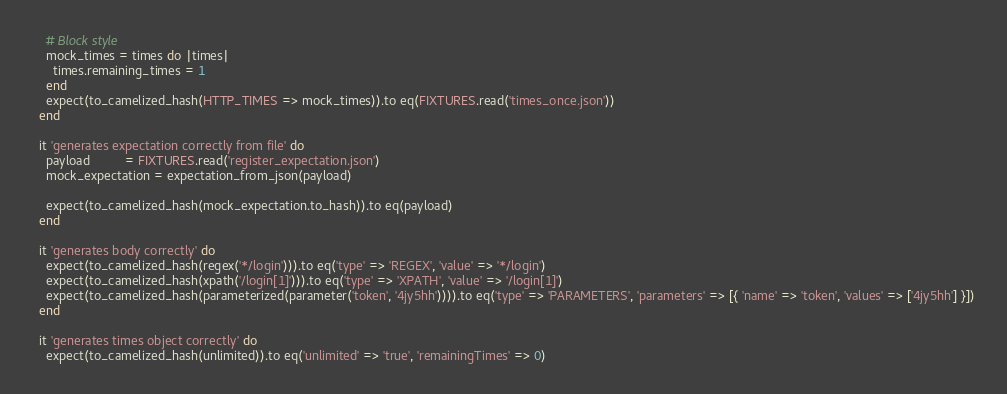<code> <loc_0><loc_0><loc_500><loc_500><_Ruby_>
    # Block style
    mock_times = times do |times|
      times.remaining_times = 1
    end
    expect(to_camelized_hash(HTTP_TIMES => mock_times)).to eq(FIXTURES.read('times_once.json'))
  end

  it 'generates expectation correctly from file' do
    payload          = FIXTURES.read('register_expectation.json')
    mock_expectation = expectation_from_json(payload)

    expect(to_camelized_hash(mock_expectation.to_hash)).to eq(payload)
  end

  it 'generates body correctly' do
    expect(to_camelized_hash(regex('*/login'))).to eq('type' => 'REGEX', 'value' => '*/login')
    expect(to_camelized_hash(xpath('/login[1]'))).to eq('type' => 'XPATH', 'value' => '/login[1]')
    expect(to_camelized_hash(parameterized(parameter('token', '4jy5hh')))).to eq('type' => 'PARAMETERS', 'parameters' => [{ 'name' => 'token', 'values' => ['4jy5hh'] }])
  end

  it 'generates times object correctly' do
    expect(to_camelized_hash(unlimited)).to eq('unlimited' => 'true', 'remainingTimes' => 0)</code> 